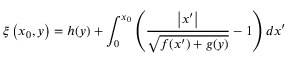<formula> <loc_0><loc_0><loc_500><loc_500>\xi \left ( x _ { 0 } , y \right ) = h ( y ) + \int _ { 0 } ^ { x _ { 0 } } \left ( \frac { \left | x ^ { \prime } \right | } { \sqrt { f ( x ^ { \prime } ) + g ( y ) } } - 1 \right ) d x ^ { \prime }</formula> 